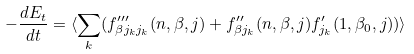<formula> <loc_0><loc_0><loc_500><loc_500>- \frac { d E _ { t } } { d t } = \langle \sum _ { k } ( f ^ { \prime \prime \prime } _ { \beta j _ { k } j _ { k } } ( n , \beta , j ) + f ^ { \prime \prime } _ { \beta j _ { k } } ( n , \beta , j ) f ^ { \prime } _ { j _ { k } } ( 1 , \beta _ { 0 } , j ) ) \rangle</formula> 